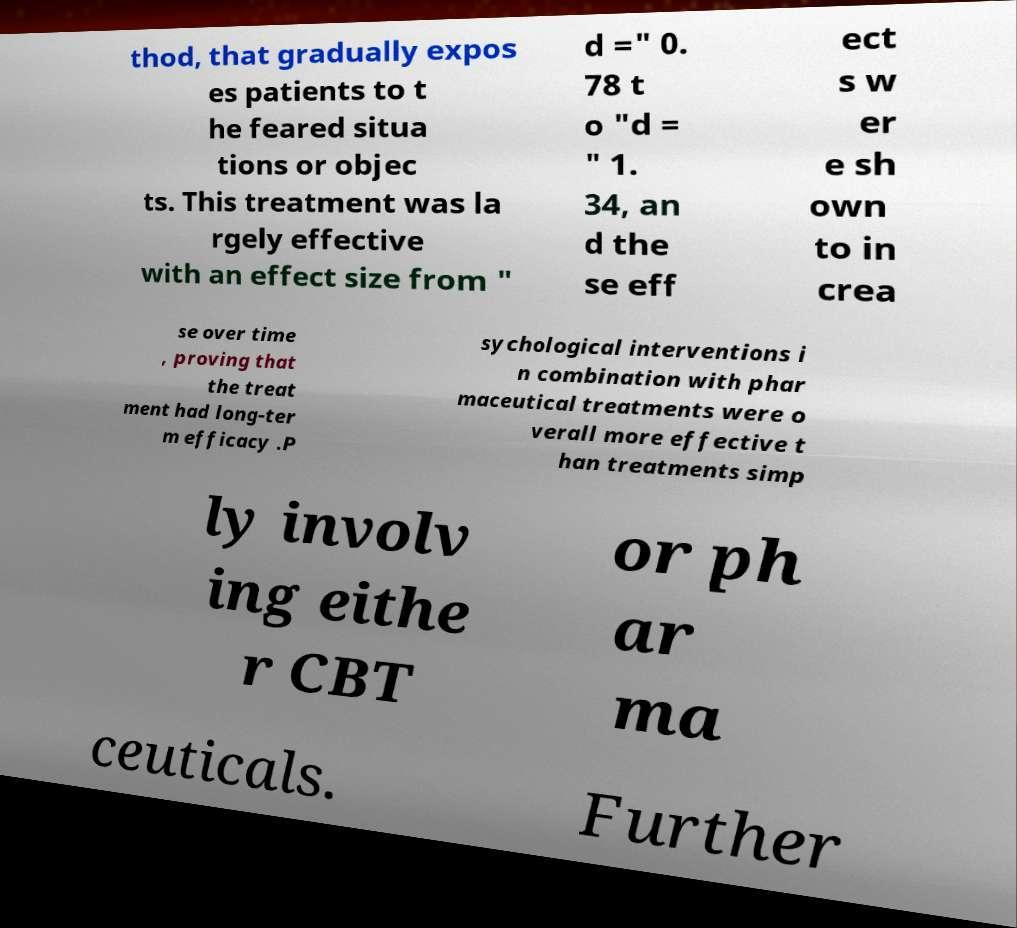Can you accurately transcribe the text from the provided image for me? thod, that gradually expos es patients to t he feared situa tions or objec ts. This treatment was la rgely effective with an effect size from " d =" 0. 78 t o "d = " 1. 34, an d the se eff ect s w er e sh own to in crea se over time , proving that the treat ment had long-ter m efficacy .P sychological interventions i n combination with phar maceutical treatments were o verall more effective t han treatments simp ly involv ing eithe r CBT or ph ar ma ceuticals. Further 